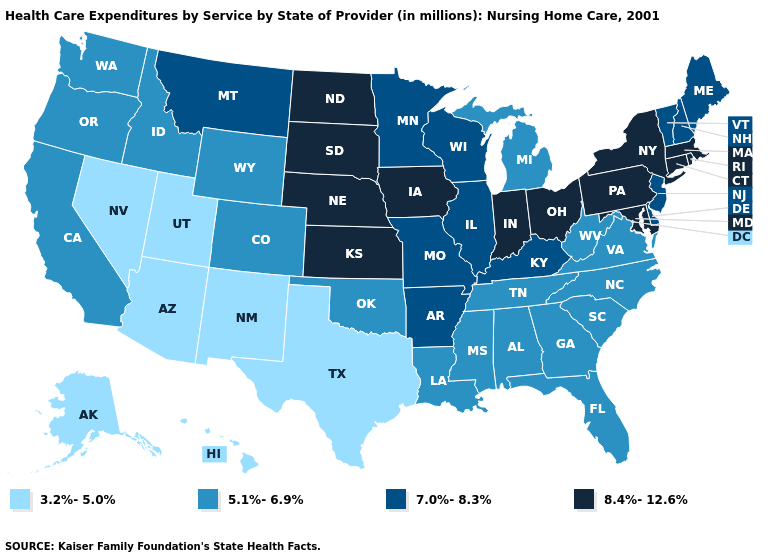Which states have the lowest value in the West?
Write a very short answer. Alaska, Arizona, Hawaii, Nevada, New Mexico, Utah. Does the map have missing data?
Concise answer only. No. Does South Carolina have a lower value than Hawaii?
Concise answer only. No. Does the first symbol in the legend represent the smallest category?
Concise answer only. Yes. What is the value of Louisiana?
Answer briefly. 5.1%-6.9%. What is the highest value in states that border Mississippi?
Concise answer only. 7.0%-8.3%. Name the states that have a value in the range 8.4%-12.6%?
Write a very short answer. Connecticut, Indiana, Iowa, Kansas, Maryland, Massachusetts, Nebraska, New York, North Dakota, Ohio, Pennsylvania, Rhode Island, South Dakota. Does the map have missing data?
Quick response, please. No. Does the first symbol in the legend represent the smallest category?
Give a very brief answer. Yes. What is the value of North Dakota?
Give a very brief answer. 8.4%-12.6%. What is the lowest value in states that border Texas?
Keep it brief. 3.2%-5.0%. Which states have the lowest value in the USA?
Concise answer only. Alaska, Arizona, Hawaii, Nevada, New Mexico, Texas, Utah. What is the lowest value in the South?
Be succinct. 3.2%-5.0%. Name the states that have a value in the range 7.0%-8.3%?
Be succinct. Arkansas, Delaware, Illinois, Kentucky, Maine, Minnesota, Missouri, Montana, New Hampshire, New Jersey, Vermont, Wisconsin. What is the value of Pennsylvania?
Quick response, please. 8.4%-12.6%. 